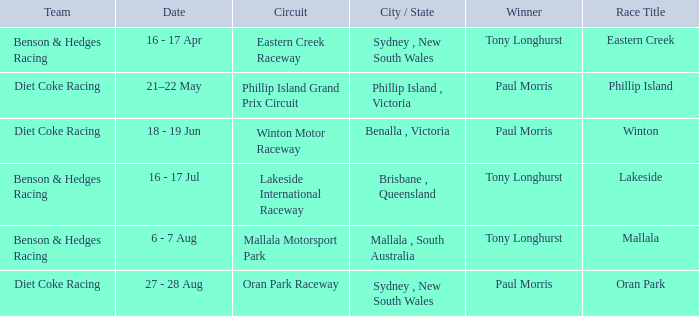When was the Mallala race held? 6 - 7 Aug. 